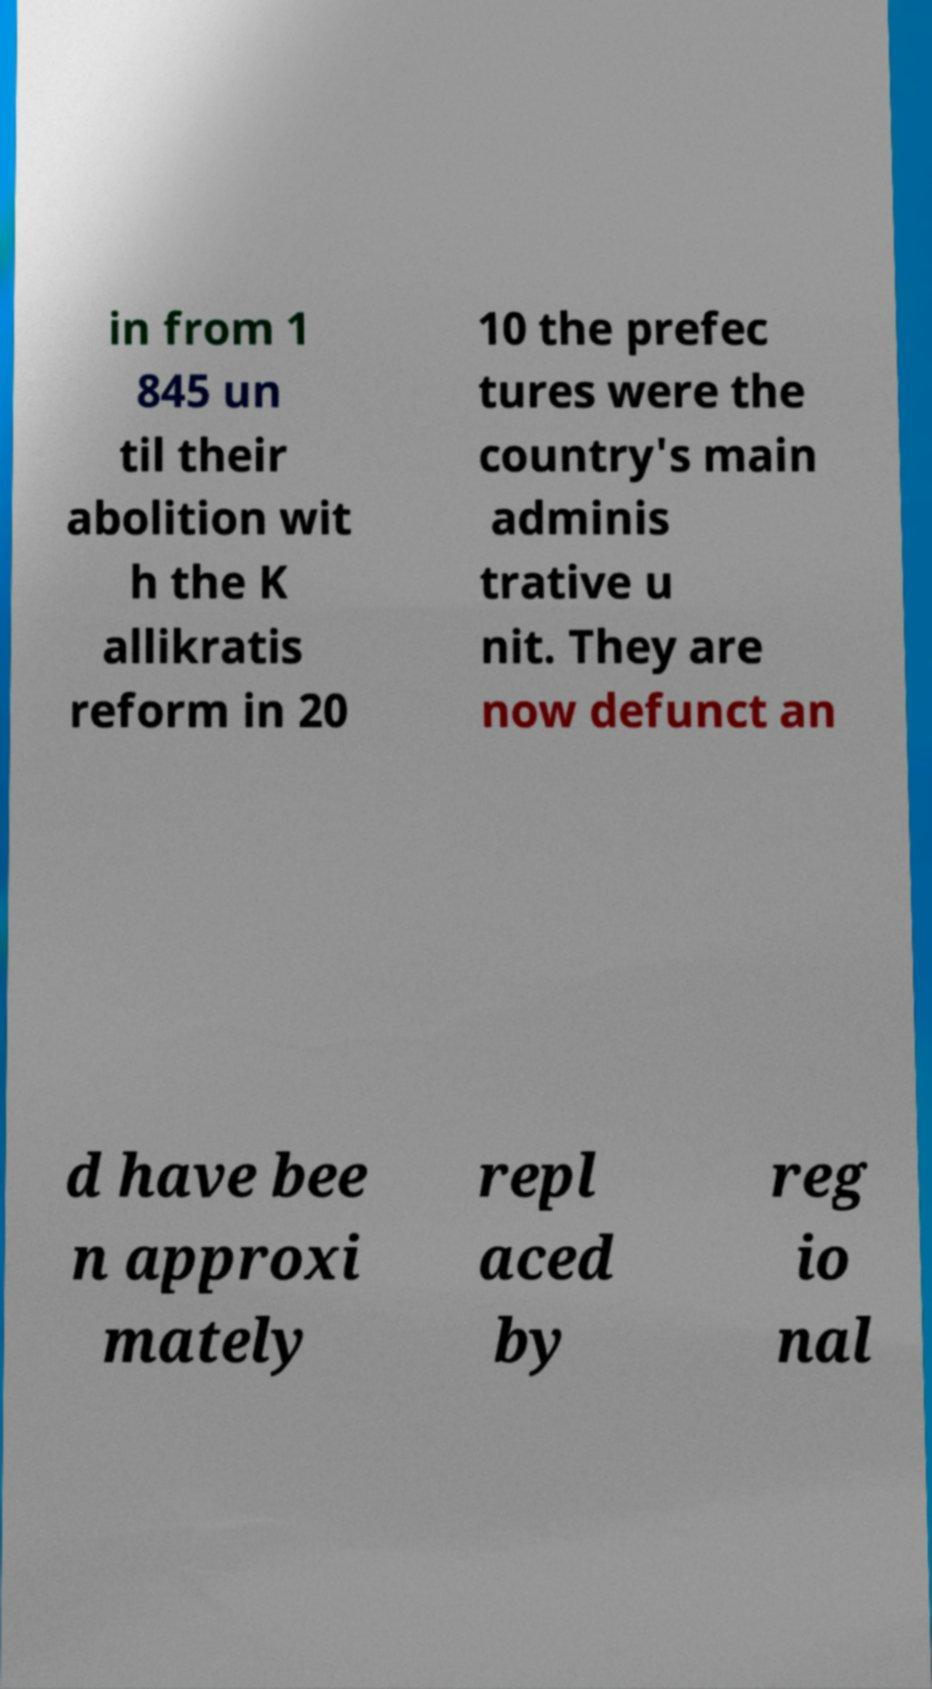I need the written content from this picture converted into text. Can you do that? in from 1 845 un til their abolition wit h the K allikratis reform in 20 10 the prefec tures were the country's main adminis trative u nit. They are now defunct an d have bee n approxi mately repl aced by reg io nal 